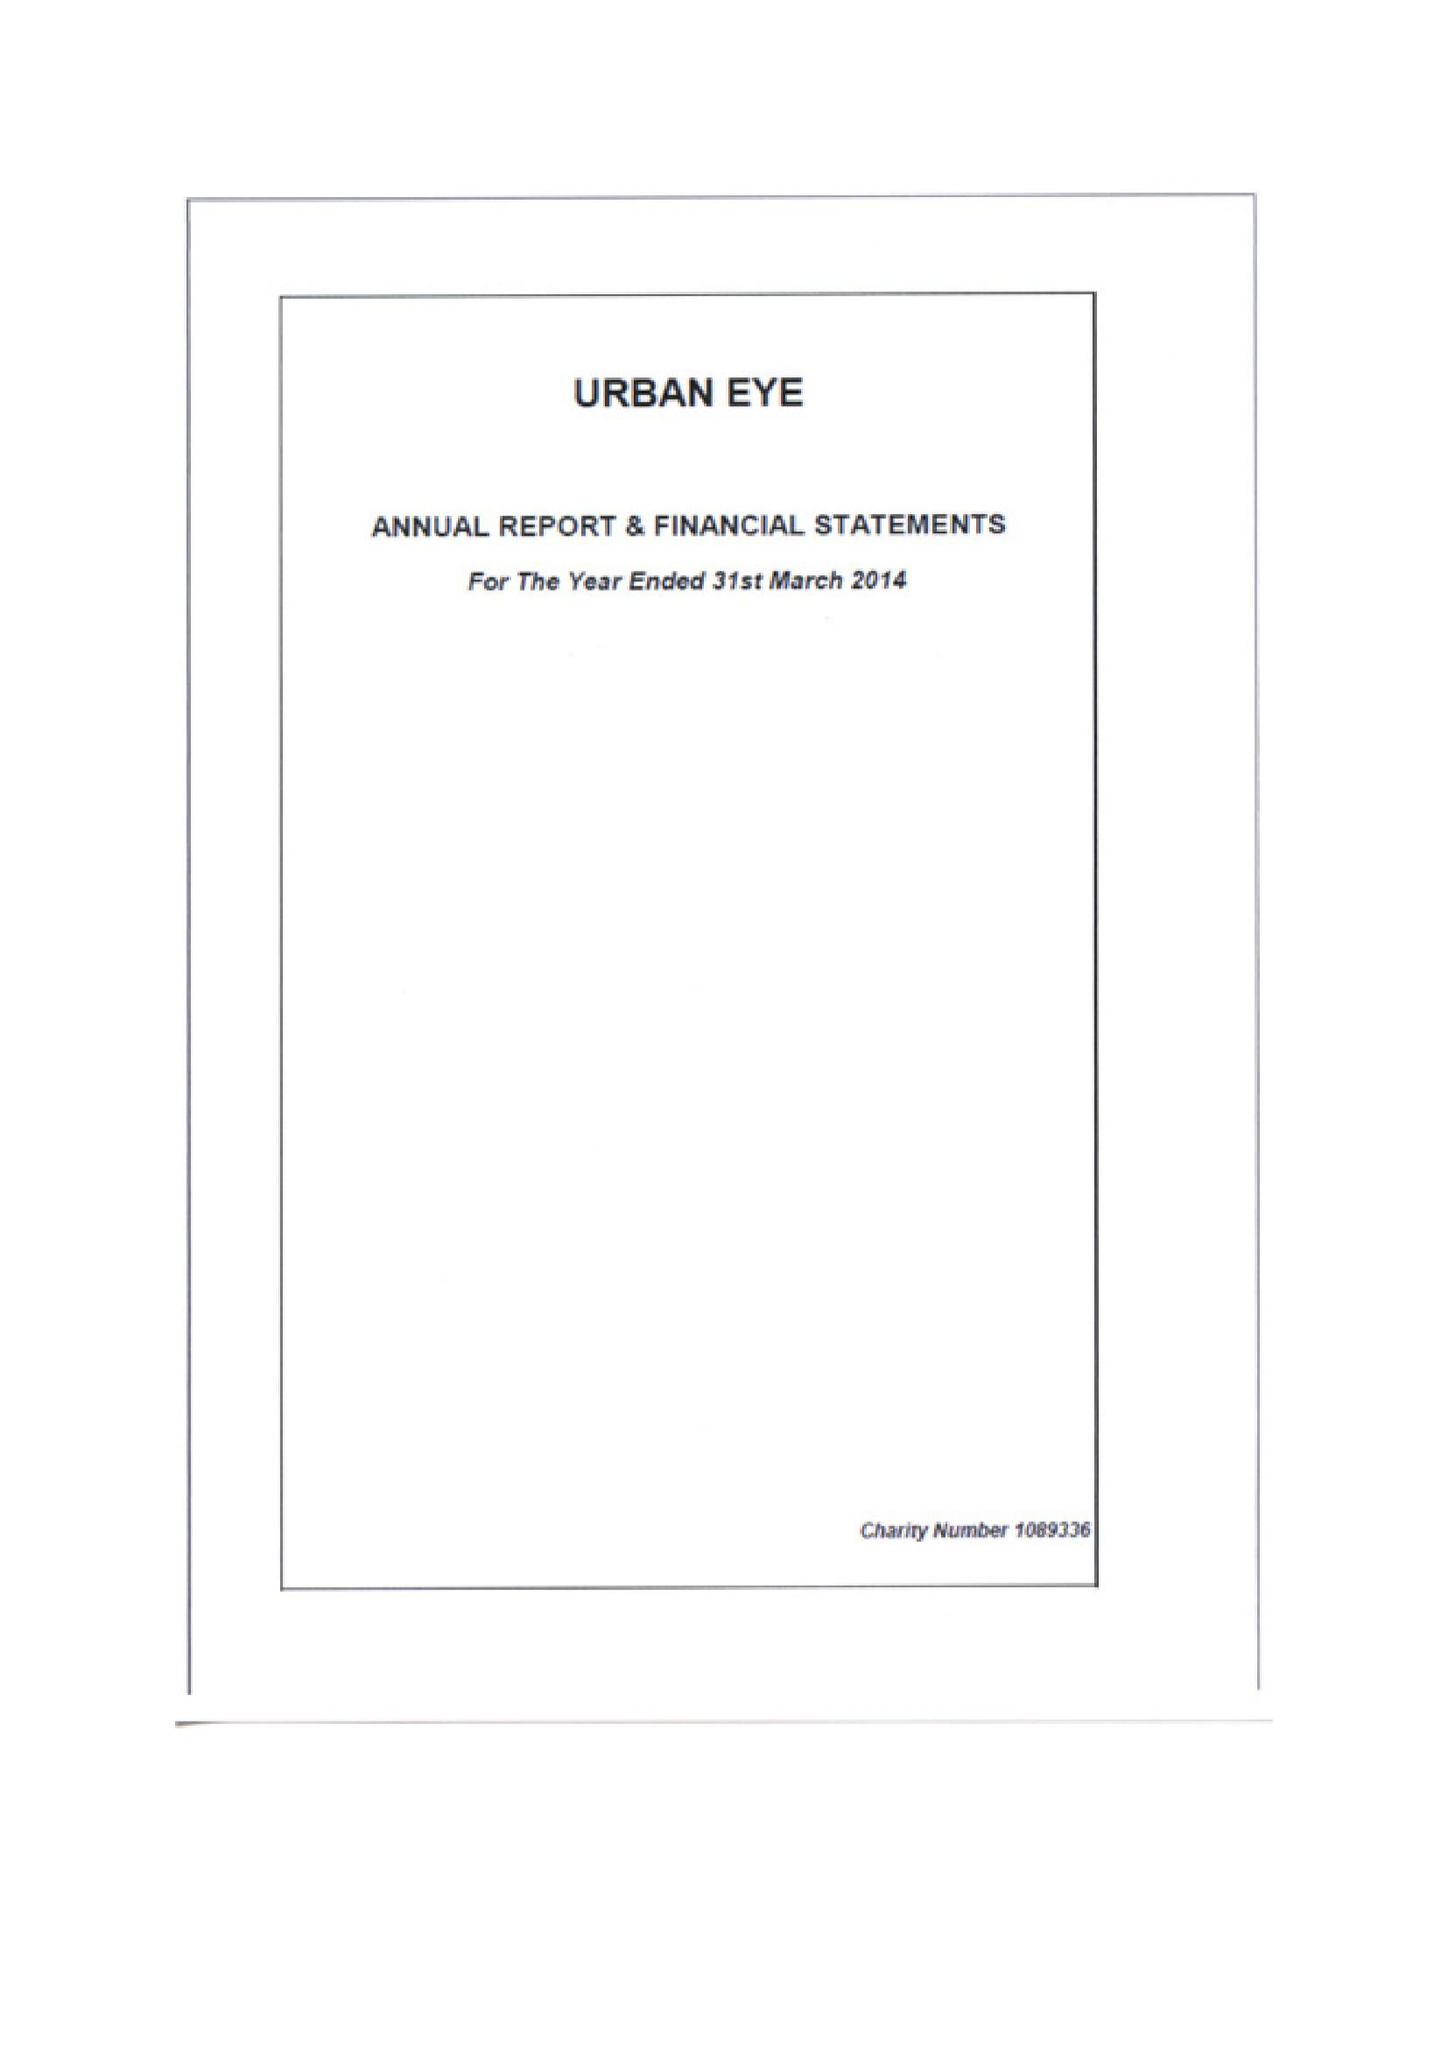What is the value for the charity_number?
Answer the question using a single word or phrase. 1089336 